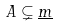<formula> <loc_0><loc_0><loc_500><loc_500>A \subsetneq \underline { m }</formula> 